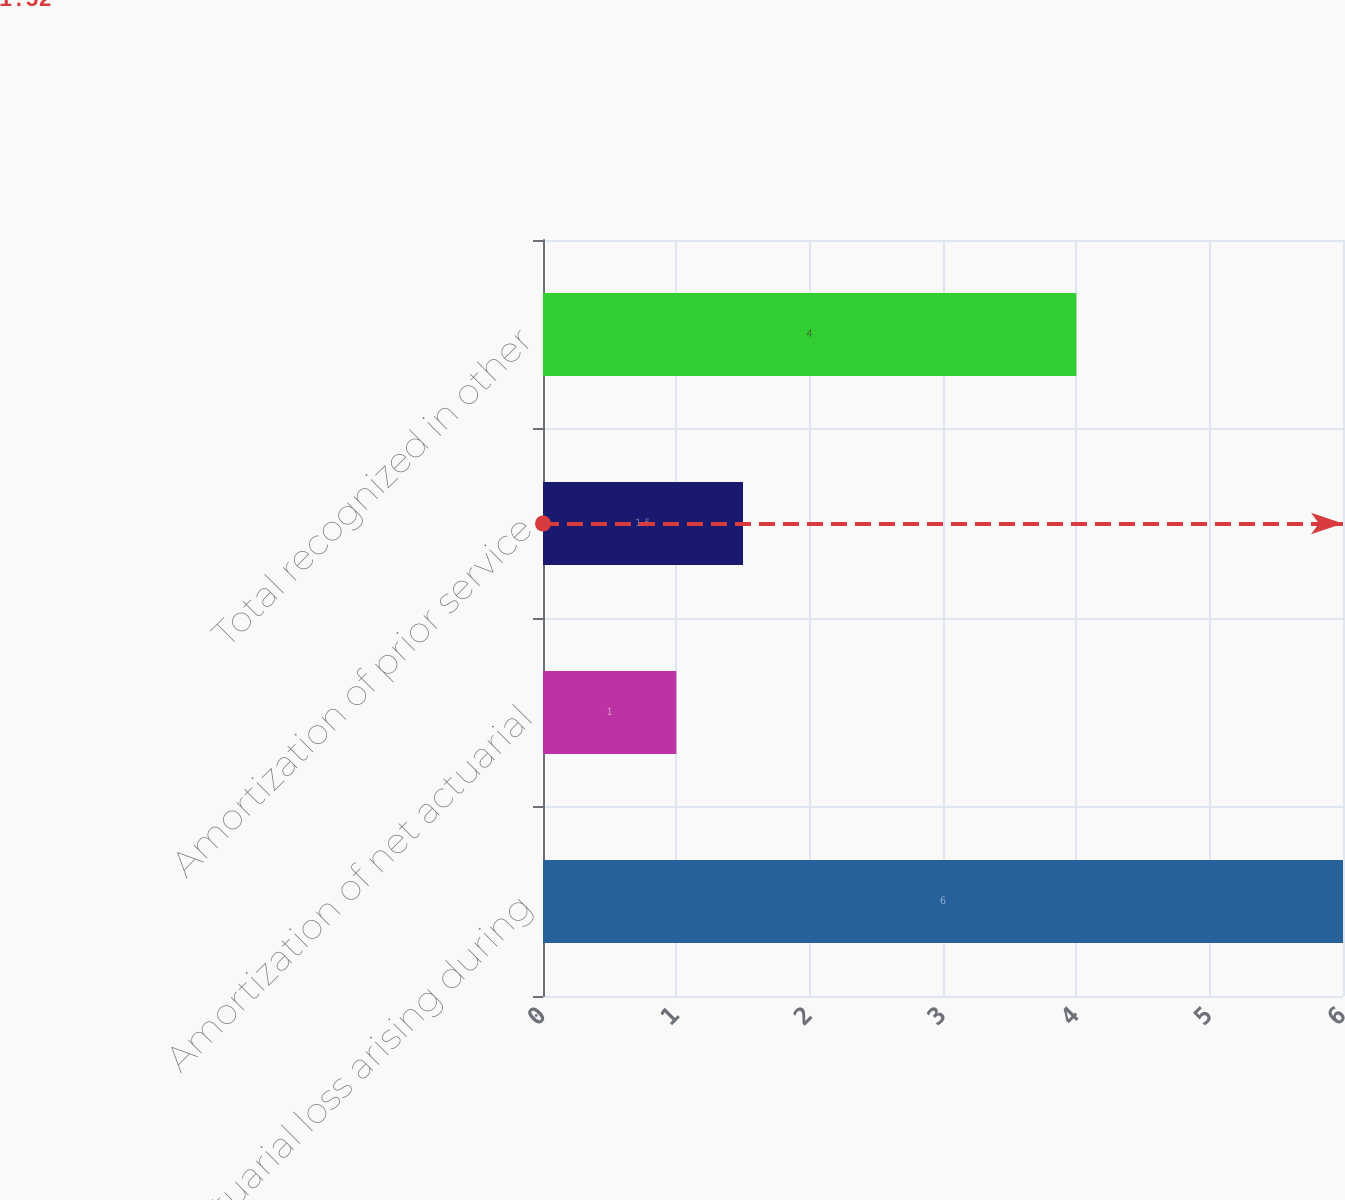Convert chart. <chart><loc_0><loc_0><loc_500><loc_500><bar_chart><fcel>Actuarial loss arising during<fcel>Amortization of net actuarial<fcel>Amortization of prior service<fcel>Total recognized in other<nl><fcel>6<fcel>1<fcel>1.5<fcel>4<nl></chart> 